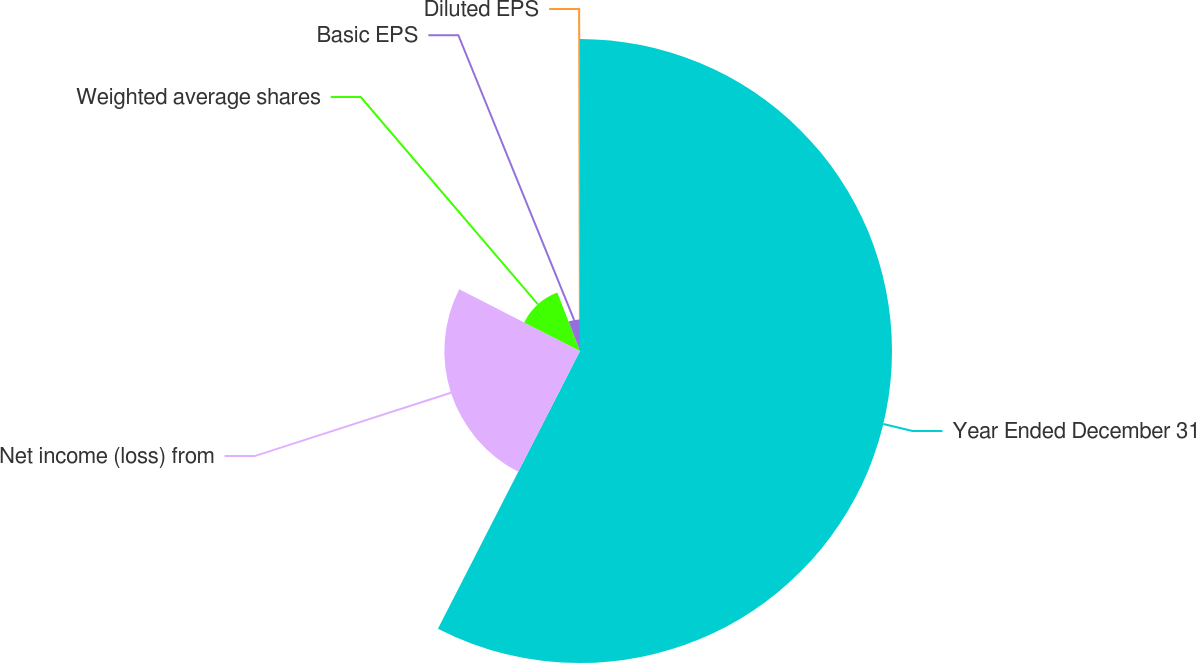Convert chart to OTSL. <chart><loc_0><loc_0><loc_500><loc_500><pie_chart><fcel>Year Ended December 31<fcel>Net income (loss) from<fcel>Weighted average shares<fcel>Basic EPS<fcel>Diluted EPS<nl><fcel>57.53%<fcel>25.01%<fcel>11.57%<fcel>5.82%<fcel>0.08%<nl></chart> 